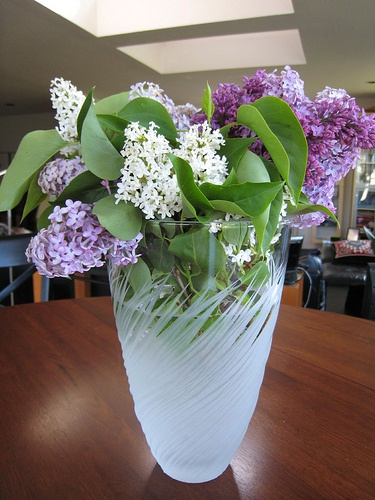Describe the objects in this image and their specific colors. I can see potted plant in gray, darkgray, and lightgray tones, dining table in gray, maroon, and brown tones, vase in gray, darkgray, and lightblue tones, and chair in gray, black, and blue tones in this image. 